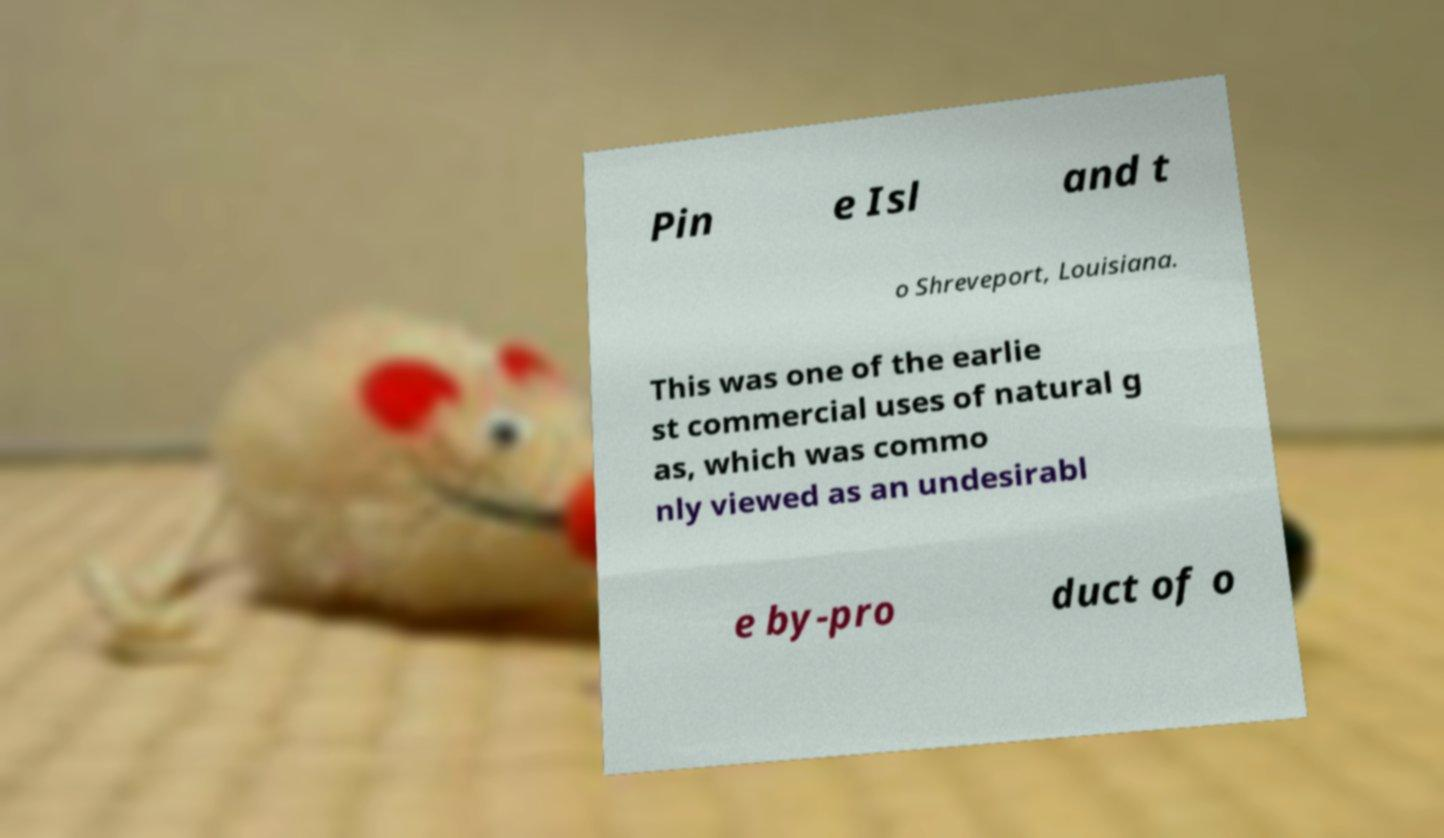Can you read and provide the text displayed in the image?This photo seems to have some interesting text. Can you extract and type it out for me? Pin e Isl and t o Shreveport, Louisiana. This was one of the earlie st commercial uses of natural g as, which was commo nly viewed as an undesirabl e by-pro duct of o 